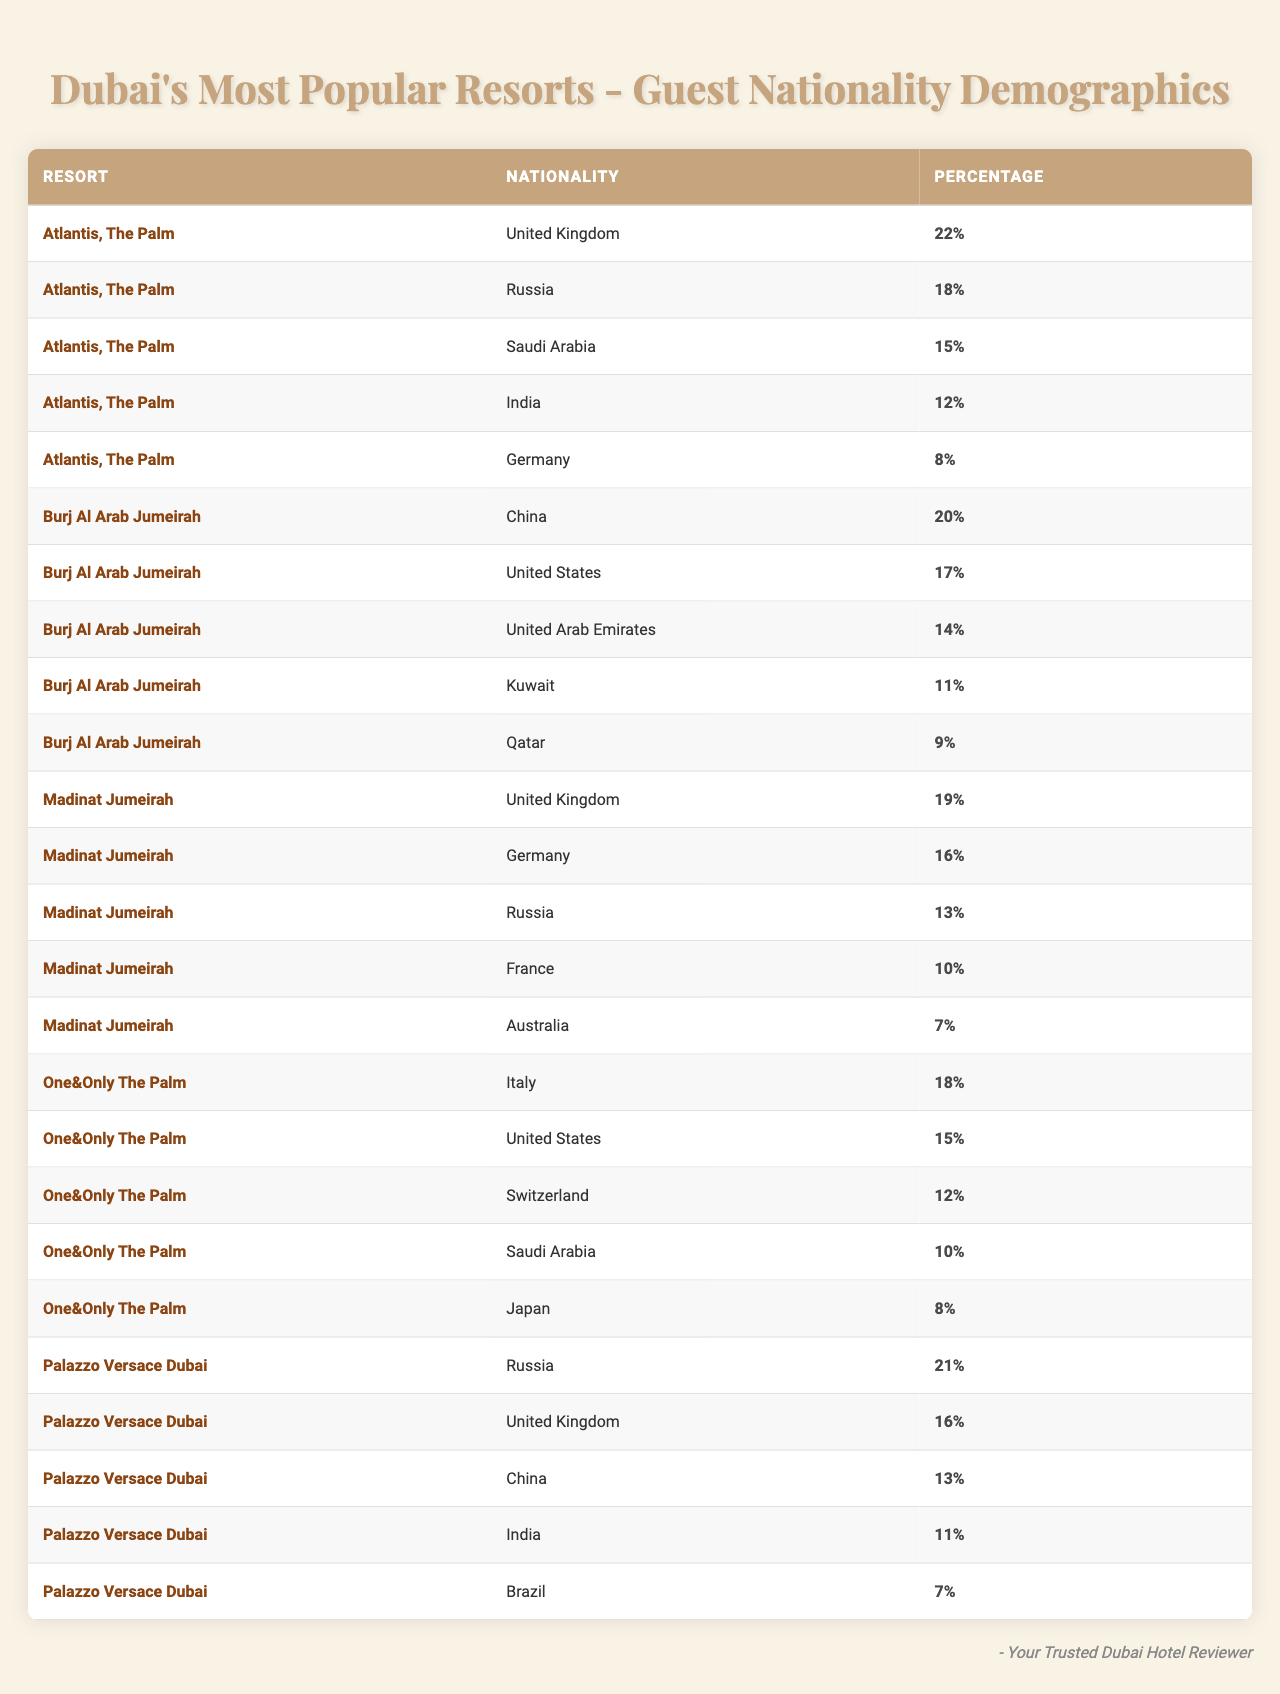What is the most represented nationality at Atlantis, The Palm? By referring to the table, the nationality with the highest percentage at Atlantis, The Palm is the United Kingdom with 22%.
Answer: United Kingdom How many nationalities are represented at Burj Al Arab Jumeirah? The table shows five nationalities listed for Burj Al Arab Jumeirah (China, United States, United Arab Emirates, Kuwait, Qatar).
Answer: Five Which resort has the highest percentage of Russian guests? The data indicates that Palazzo Versace Dubai has the highest percentage of Russian guests at 21%.
Answer: Palazzo Versace Dubai What is the total percentage of guests from the United Kingdom across all resorts? The percentages for the United Kingdom are 22% at Atlantis, The Palm, 19% at Madinat Jumeirah, and 16% at Palazzo Versace Dubai, summing them gives 22 + 19 + 16 = 57%.
Answer: 57% Is China represented at every resort in the table? The table shows China represented at Burj Al Arab Jumeirah and Palazzo Versace Dubai, but not at Atlantis, The Palm or One&Only The Palm, indicating that it is not present at every resort.
Answer: No Which nationality has the highest representation across all resorts combined? We calculate the total representation for each nationality by summing their percentages. The United Kingdom leads with 22 + 19 + 16 = 57%. Thus, it has the highest representation.
Answer: United Kingdom What percentage of guests at One&Only The Palm are from Saudi Arabia and Japan combined? The table lists Saudi Arabia's percentage at 10% and Japan's at 8%. Therefore, 10 + 8 = 18%.
Answer: 18% Which resort has the least representation from the United States? At One&Only The Palm, the representation from the United States is 15%, while at Burj Al Arab Jumeirah it's 17%. Therefore, One&Only The Palm has the least representation.
Answer: One&Only The Palm What is the average percentage of guests from Germany across all resorts? The representation of Germany is 8% at Atlantis, The Palm, 16% at Madinat Jumeirah, and 0% at the other resorts. To find the average: (8 + 16) / 2 = 12%.
Answer: 12% Does the table include any guest representation from Brazil? The table shows Brazil represented only at Palazzo Versace Dubai with a percentage of 7%.
Answer: Yes 